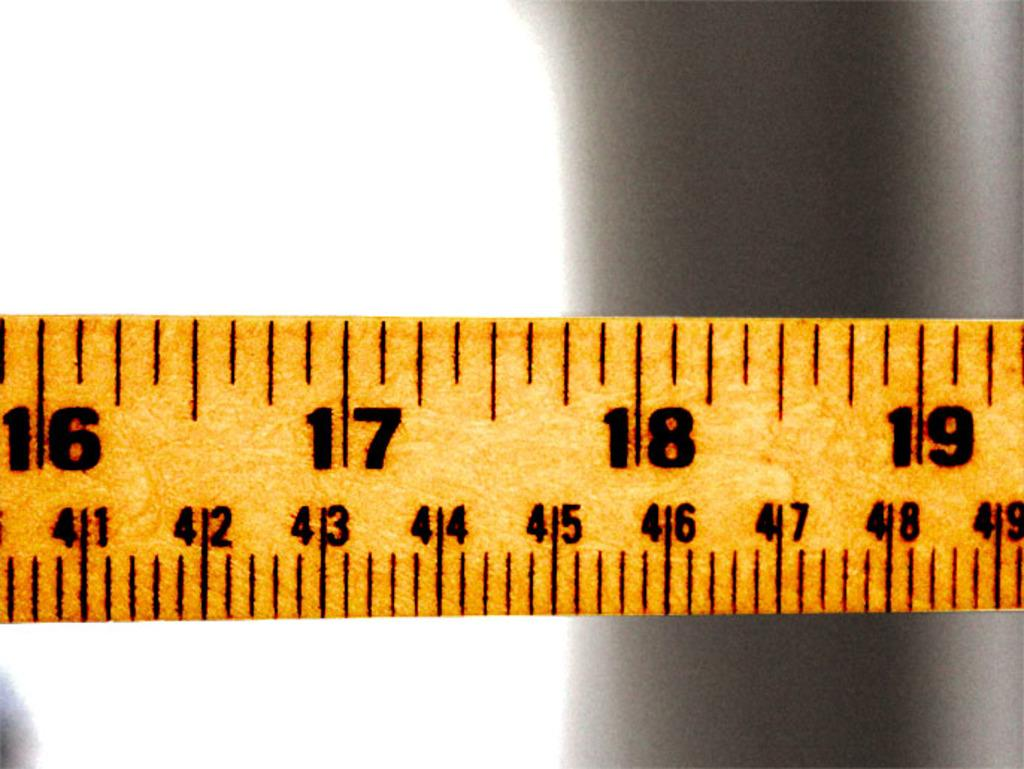<image>
Summarize the visual content of the image. A measuring tape is shown with the numbers 16 through 19 visible along the top edge. 